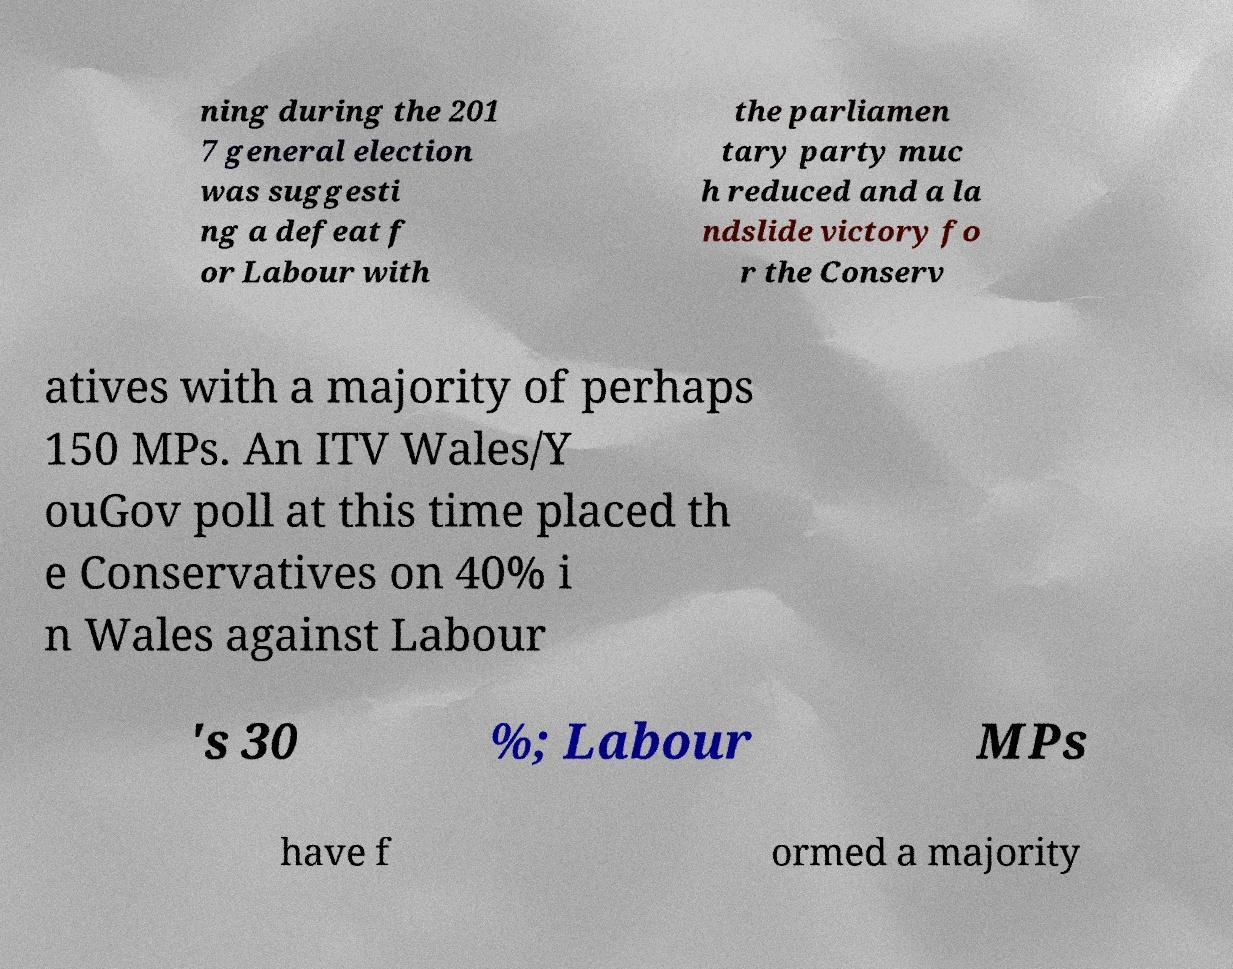Please read and relay the text visible in this image. What does it say? ning during the 201 7 general election was suggesti ng a defeat f or Labour with the parliamen tary party muc h reduced and a la ndslide victory fo r the Conserv atives with a majority of perhaps 150 MPs. An ITV Wales/Y ouGov poll at this time placed th e Conservatives on 40% i n Wales against Labour 's 30 %; Labour MPs have f ormed a majority 